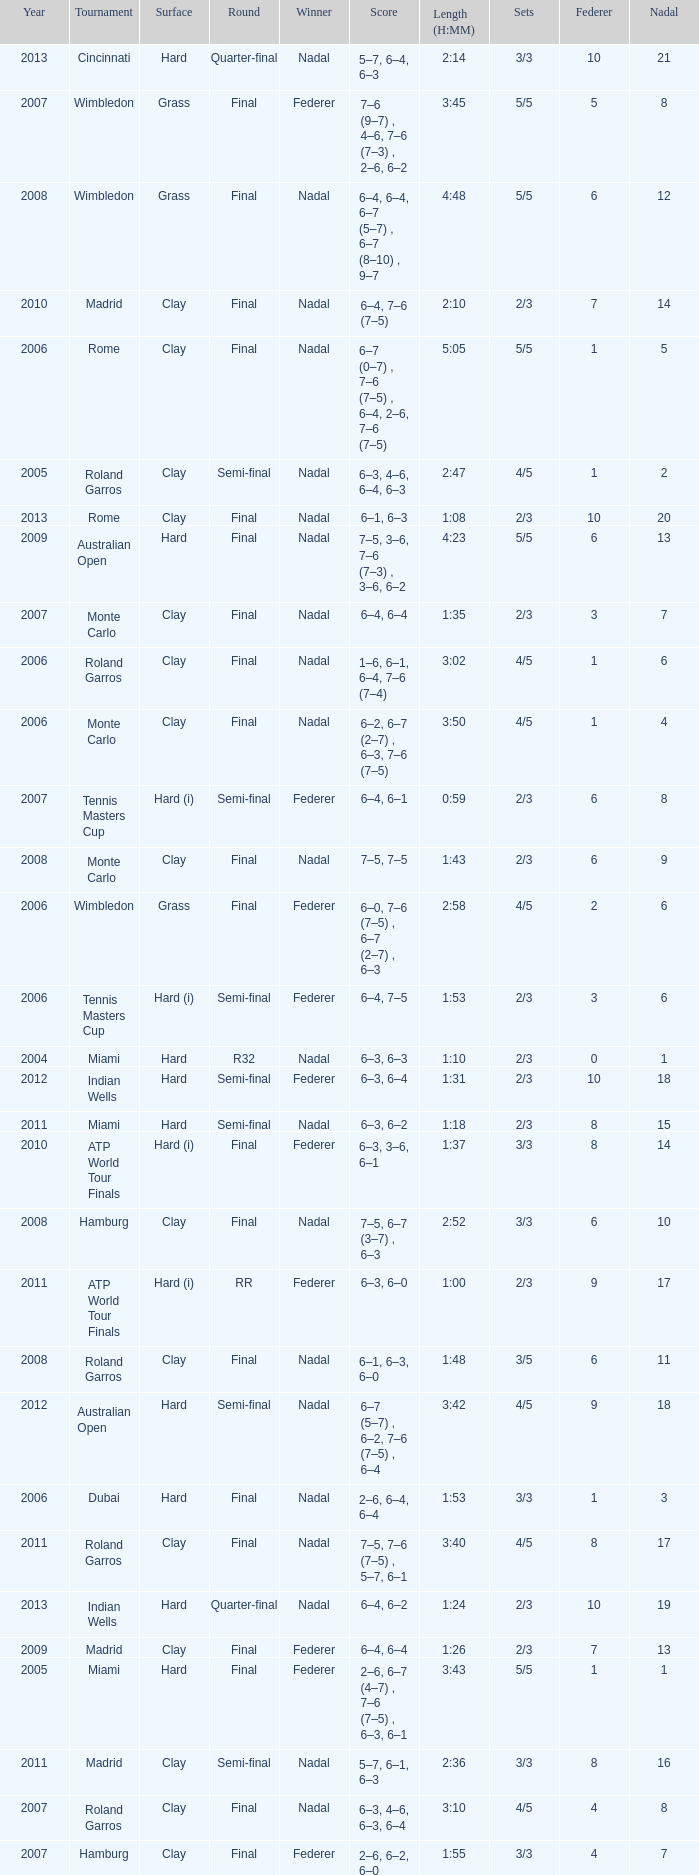What tournament did Nadal win and had a nadal of 16? Madrid. 